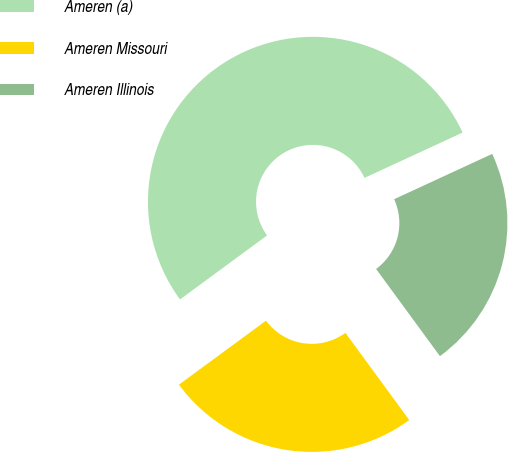<chart> <loc_0><loc_0><loc_500><loc_500><pie_chart><fcel>Ameren (a)<fcel>Ameren Missouri<fcel>Ameren Illinois<nl><fcel>53.2%<fcel>24.97%<fcel>21.83%<nl></chart> 